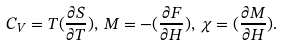<formula> <loc_0><loc_0><loc_500><loc_500>C _ { V } = T ( \frac { \partial { S } } { \partial { T } } ) , \, M = - ( \frac { \partial { F } } { \partial { H } } ) , \, \chi = ( \frac { \partial { M } } { \partial { H } } ) .</formula> 